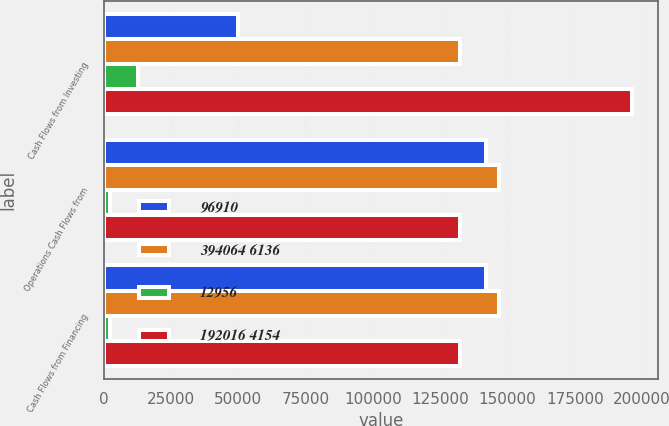<chart> <loc_0><loc_0><loc_500><loc_500><stacked_bar_chart><ecel><fcel>Cash Flows from Investing<fcel>Operations Cash Flows from<fcel>Cash Flows from Financing<nl><fcel>96910<fcel>49972<fcel>142078<fcel>142078<nl><fcel>394064 6136<fcel>132506<fcel>147050<fcel>147050<nl><fcel>12956<fcel>12956<fcel>2355<fcel>2355<nl><fcel>192016 4154<fcel>196170<fcel>132506<fcel>132467<nl></chart> 